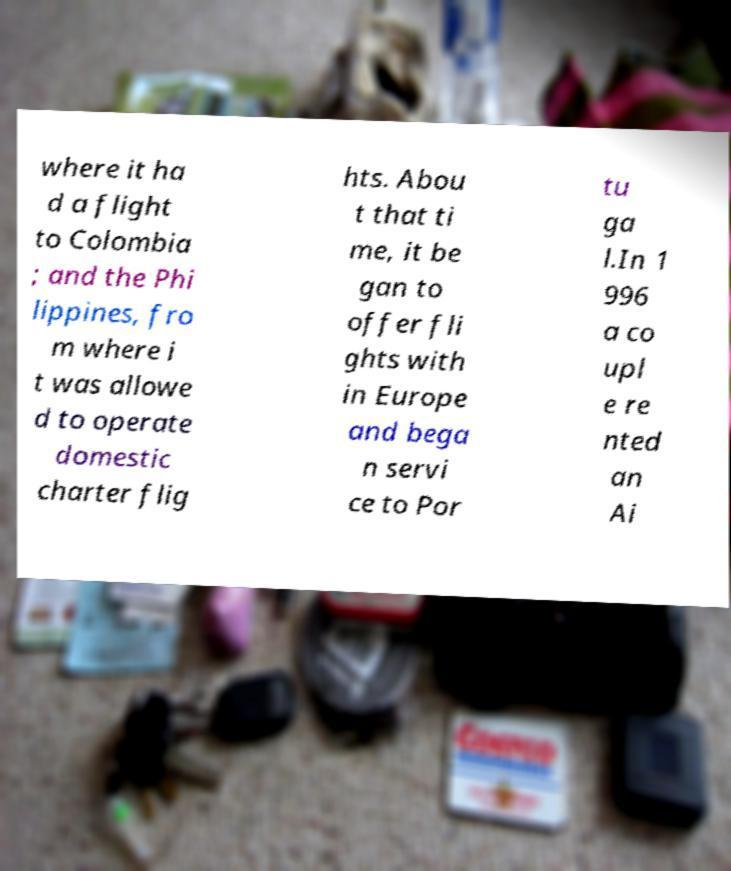Can you accurately transcribe the text from the provided image for me? where it ha d a flight to Colombia ; and the Phi lippines, fro m where i t was allowe d to operate domestic charter flig hts. Abou t that ti me, it be gan to offer fli ghts with in Europe and bega n servi ce to Por tu ga l.In 1 996 a co upl e re nted an Ai 